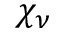<formula> <loc_0><loc_0><loc_500><loc_500>\chi _ { \nu }</formula> 